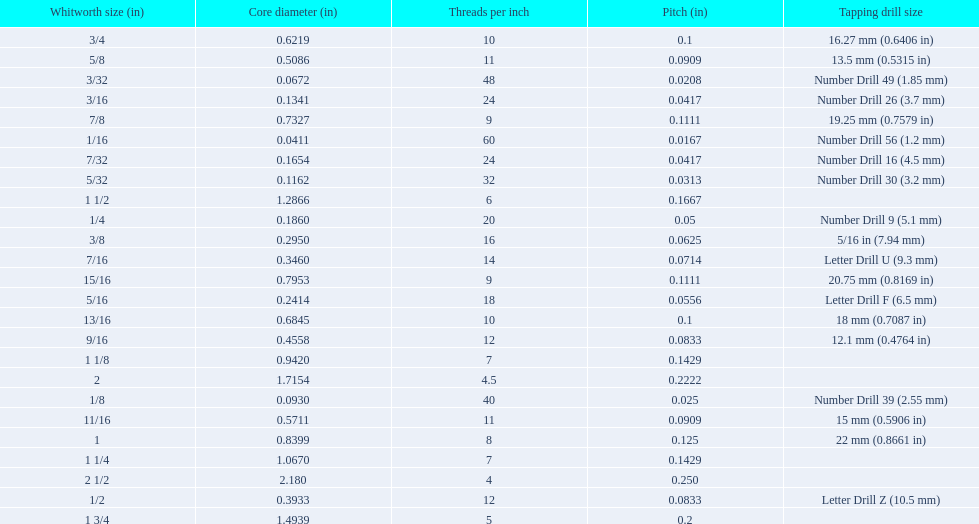What are all of the whitworth sizes? 1/16, 3/32, 1/8, 5/32, 3/16, 7/32, 1/4, 5/16, 3/8, 7/16, 1/2, 9/16, 5/8, 11/16, 3/4, 13/16, 7/8, 15/16, 1, 1 1/8, 1 1/4, 1 1/2, 1 3/4, 2, 2 1/2. How many threads per inch are in each size? 60, 48, 40, 32, 24, 24, 20, 18, 16, 14, 12, 12, 11, 11, 10, 10, 9, 9, 8, 7, 7, 6, 5, 4.5, 4. How many threads per inch are in the 3/16 size? 24. And which other size has the same number of threads? 7/32. 